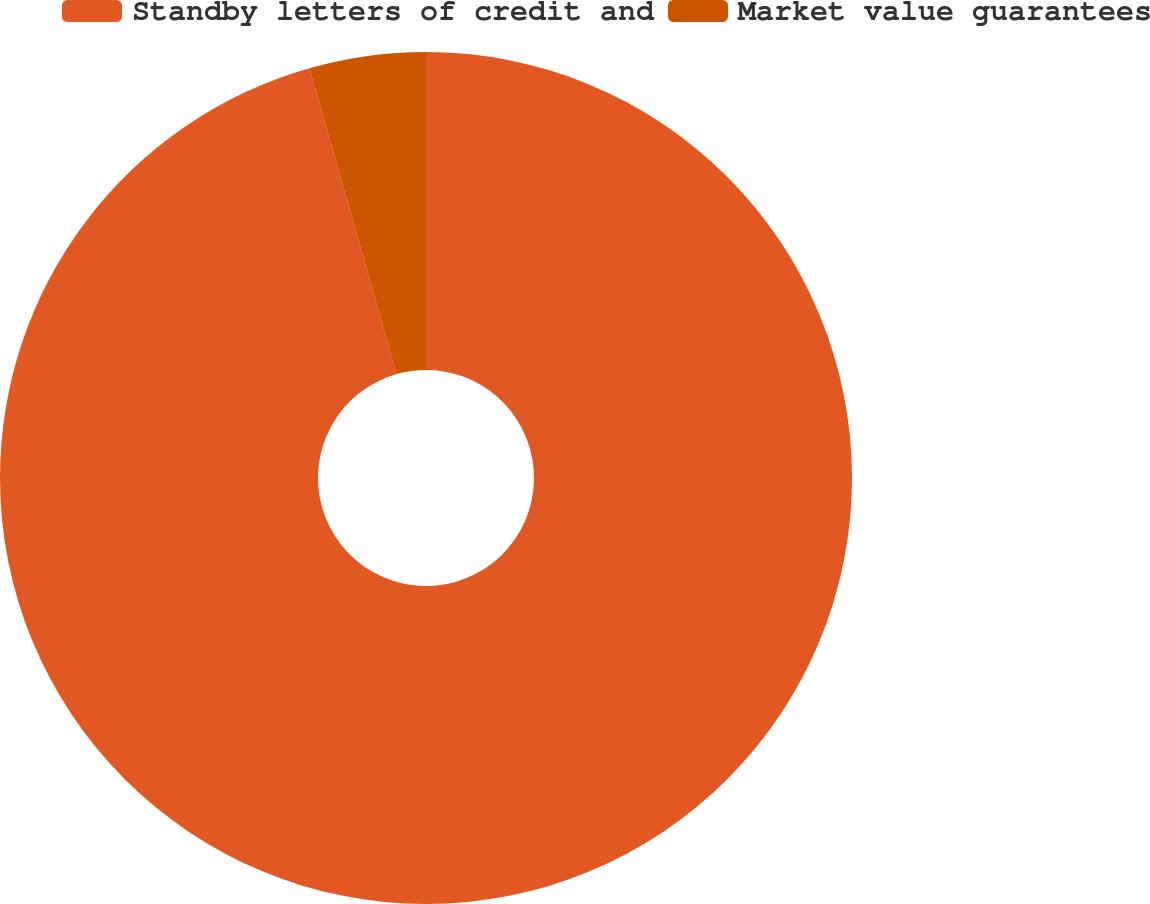Convert chart. <chart><loc_0><loc_0><loc_500><loc_500><pie_chart><fcel>Standby letters of credit and<fcel>Market value guarantees<nl><fcel>95.59%<fcel>4.41%<nl></chart> 